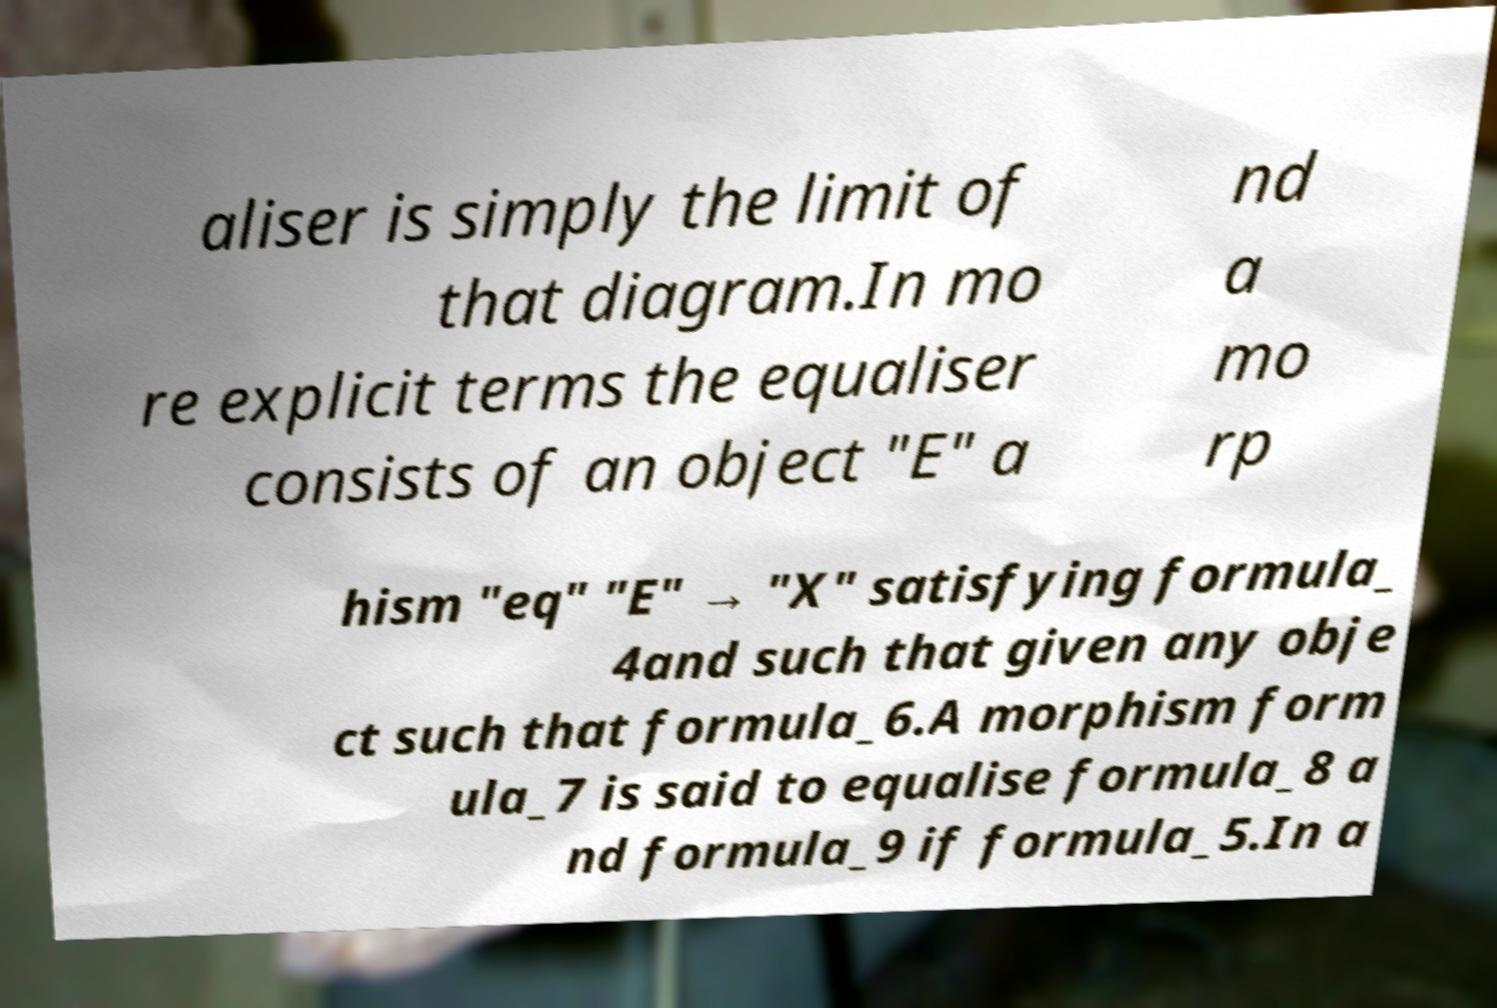Please read and relay the text visible in this image. What does it say? aliser is simply the limit of that diagram.In mo re explicit terms the equaliser consists of an object "E" a nd a mo rp hism "eq" "E" → "X" satisfying formula_ 4and such that given any obje ct such that formula_6.A morphism form ula_7 is said to equalise formula_8 a nd formula_9 if formula_5.In a 